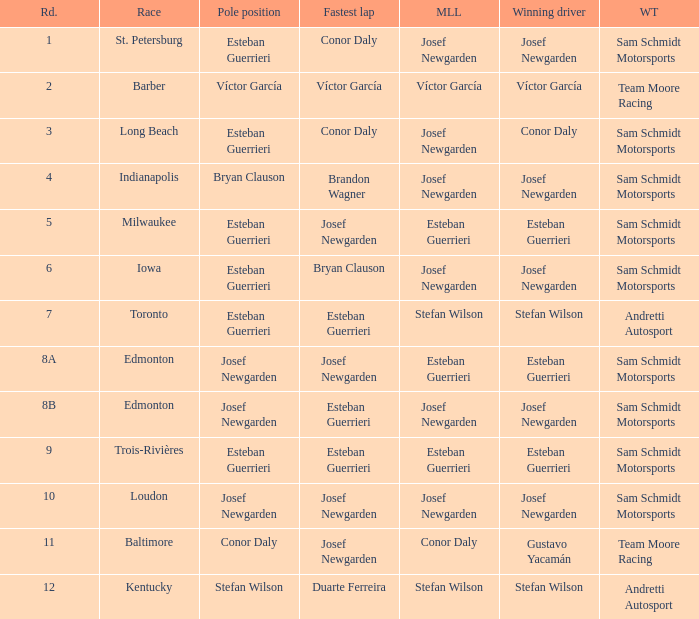Who led the most laps when brandon wagner had the fastest lap? Josef Newgarden. 